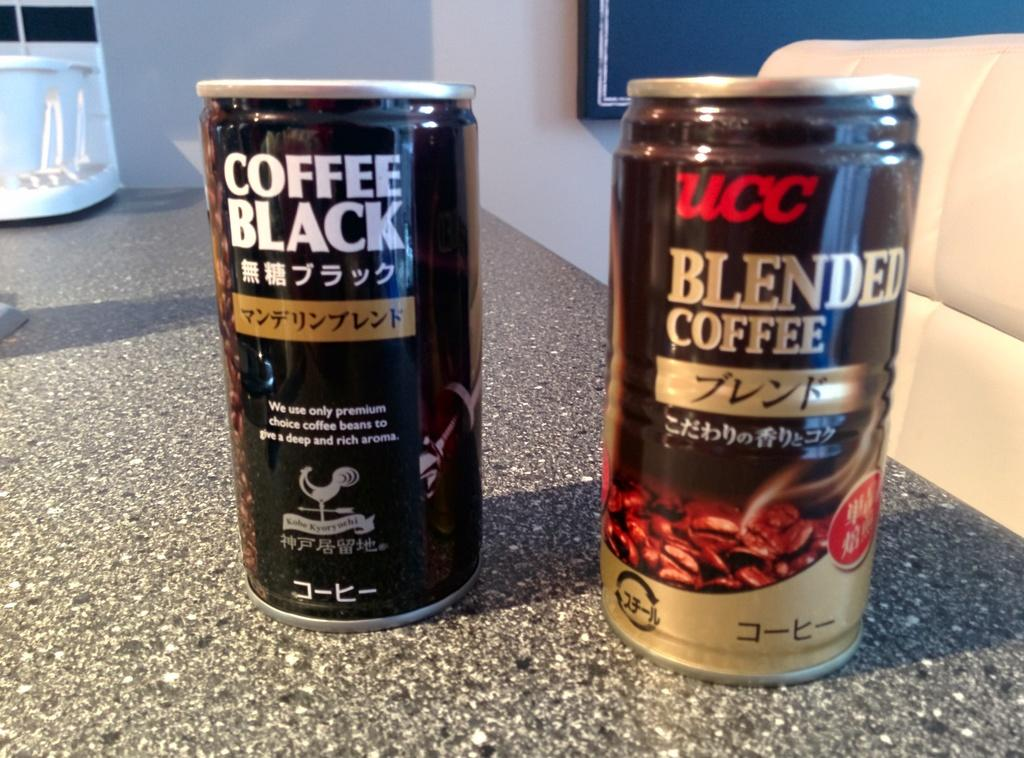<image>
Create a compact narrative representing the image presented. The can on the left has black coffee inside it 